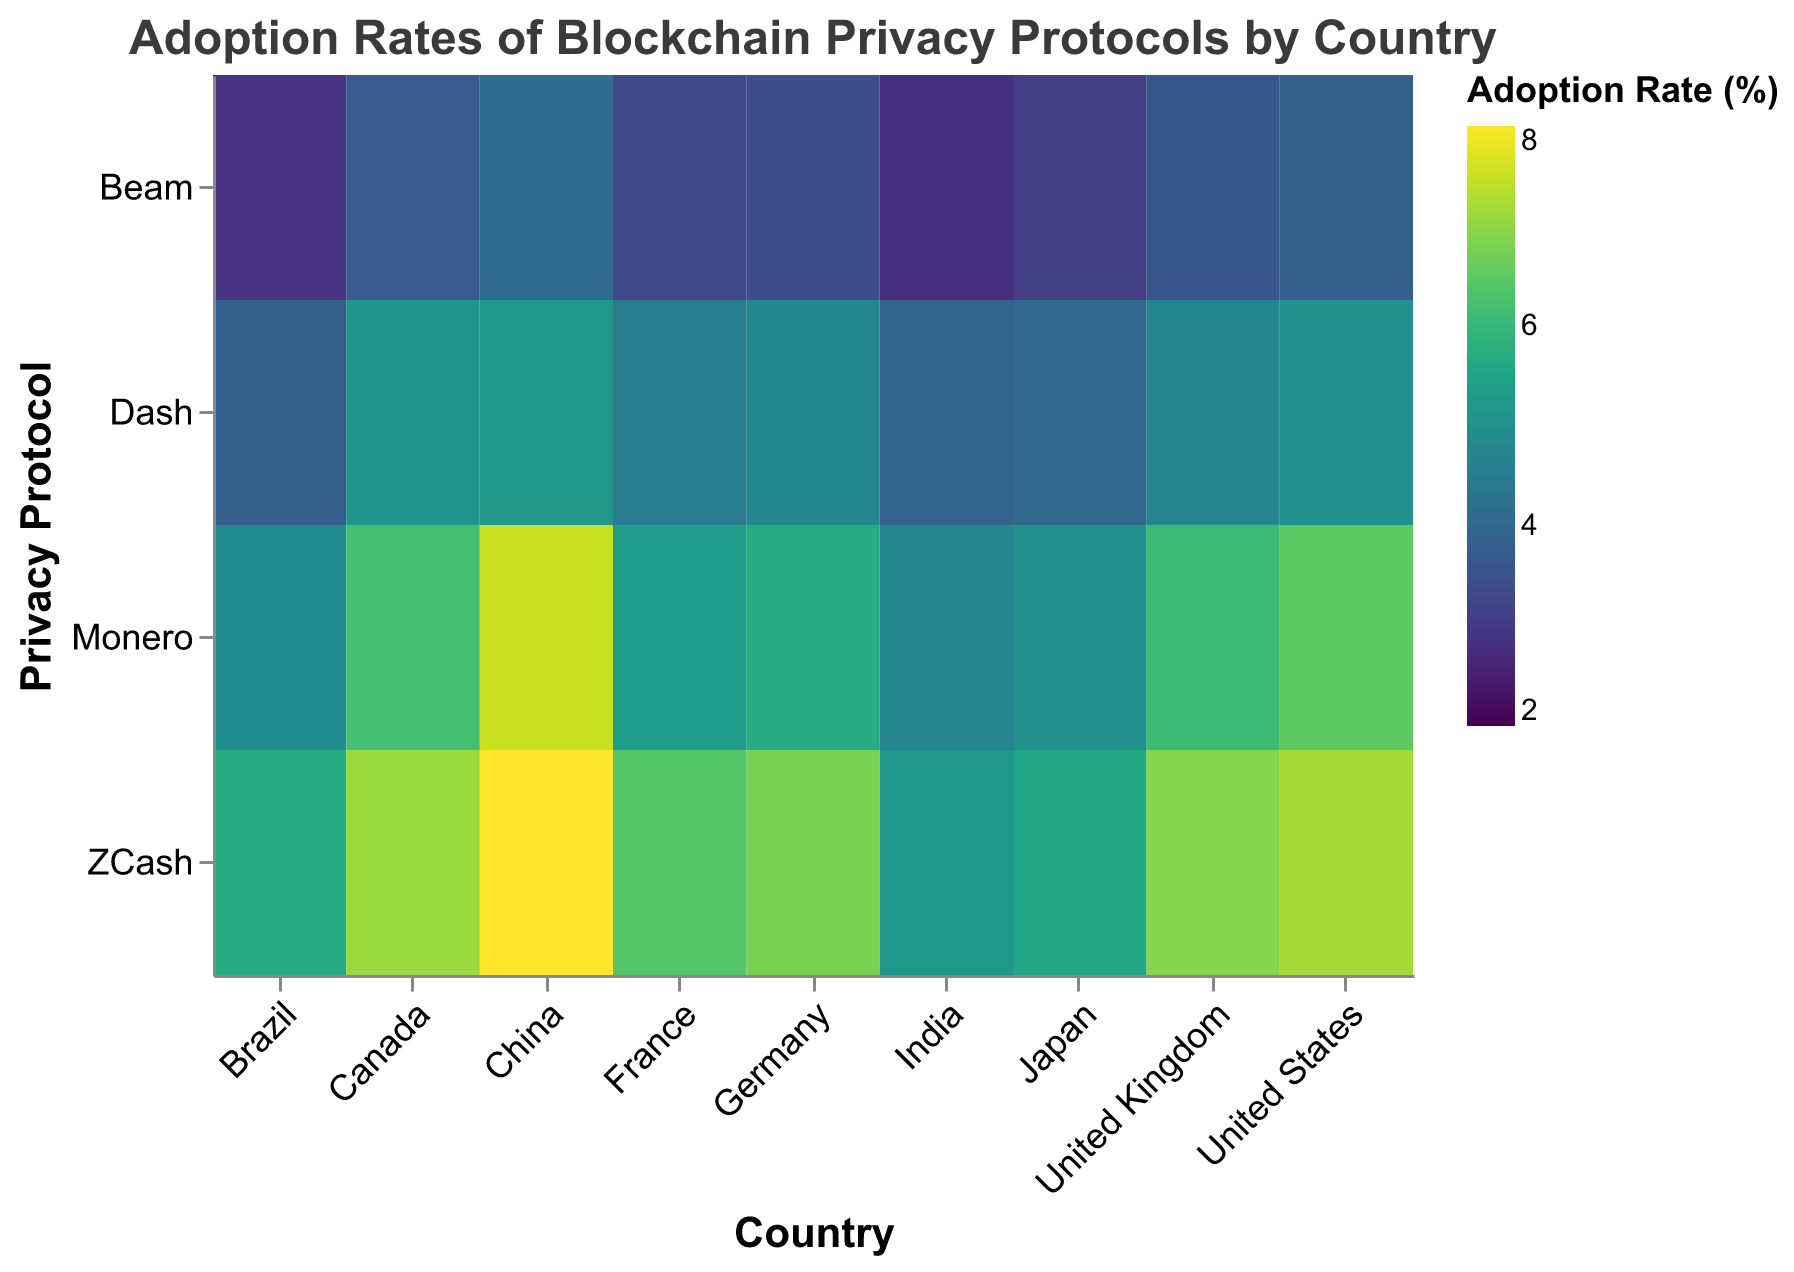What is the title of the heatmap? The title of the heatmap is displayed at the top of the figure and provides an overall description of what the heatmap represents.
Answer: Adoption Rates of Blockchain Privacy Protocols by Country Which country has the highest adoption rate for ZCash? By observing the heatmap, the highest adoption rate is indicated by the darkest color. China has the darkest color for ZCash.
Answer: China Compare the adoption rate of Monero in the United States versus Canada. Which country has a higher rate? Look at the color shades for Monero in both countries: The United States (6.5) and Canada (6.2). Compare them.
Answer: United States What is the adoption rate of Dash in India? Find the cell that corresponds to Dash in India and check the color legend or the value directly.
Answer: 3.9 Which privacy protocol has the lowest adoption rate in Brazil according to the heatmap? By observing the color shades in the Brazil row, the lightest shade corresponds to the lowest adoption rate, which is Beam.
Answer: Beam Calculate the average adoption rate of Beam across all the countries shown. Sum up the Beam adoption rates in all countries and then divide by the number of countries. Values are: 3.8 (US) + 3.4 (Germany) + 4.1 (China) + 2.8 (India) + 3.6 (UK) + 3.3 (France) + 2.9 (Brazil) + 3.7 (Canada) + 3.1 (Japan). The average is (3.8+3.4+4.1+2.8+3.6+3.3+2.9+3.7+3.1)/9 = 3.4
Answer: 3.4 Between France and Germany, which country has a higher overall average adoption rate for all privacy protocols? Calculate the average adoption rates for all four protocols in France and Germany, then compare them. France: (6.4+5.3+4.5+3.3)/4 = 4.875; Germany: (6.8+5.7+4.8+3.4)/4 = 5.175.
Answer: Germany Identify the country-protocol pair with the highest adoption rate. The cell with the darkest color, representing the highest rate, corresponds to the country-protocol pair China and ZCash, which has a value of 8.1.
Answer: China and ZCash Is the adoption rate of Monero in the United Kingdom higher or lower than the adoption rate of Dash in Canada? Check the adoption rates in both cells: United Kingdom for Monero (6.1) and Canada for Dash (5.1). Compare them.
Answer: Higher What is the common trend in adoption rates for all privacy protocols in the United States? Observe the color trends in the United States row; note the general gradient. The adoption rates gradually decrease from ZCash to Beam.
Answer: Decreasing trend 